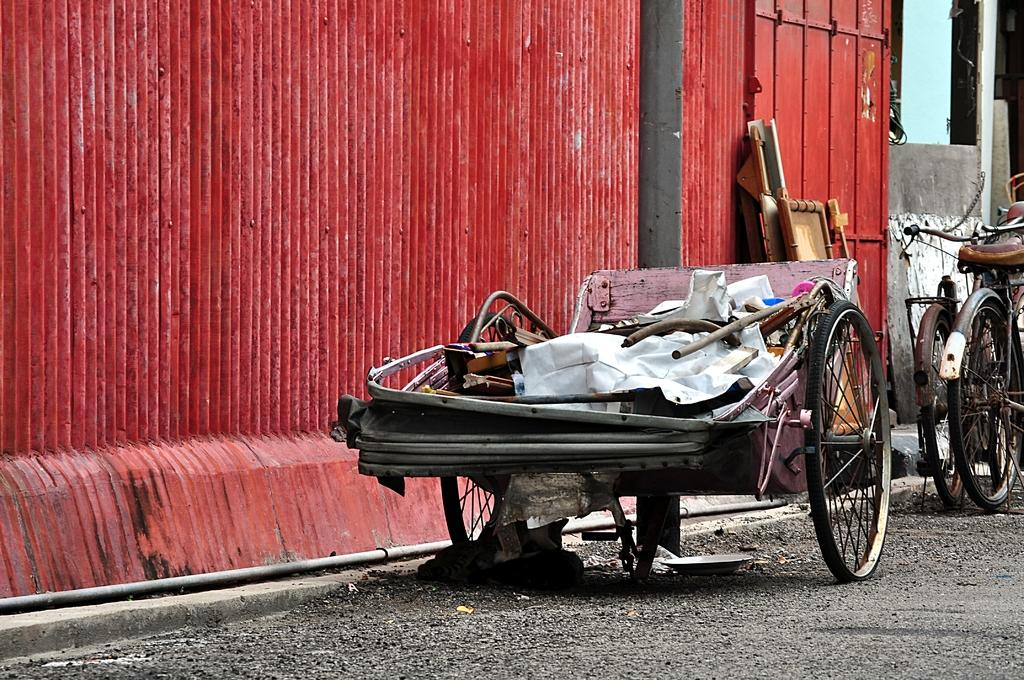What type of vehicle is in the image? There is a cart in the image. How many bicycles are in the image? There are two bicycles in the image. Where are the cart and bicycles located? The cart and bicycles are on the surface of the road. What can be seen in the background of the image? There is a metal wall in the background of the image. What type of protest is taking place in the image? There is no protest present in the image; it features a cart, bicycles, and a metal wall. What is the growth rate of the lip in the image? There is no lip present in the image, so it is not possible to determine its growth rate. 